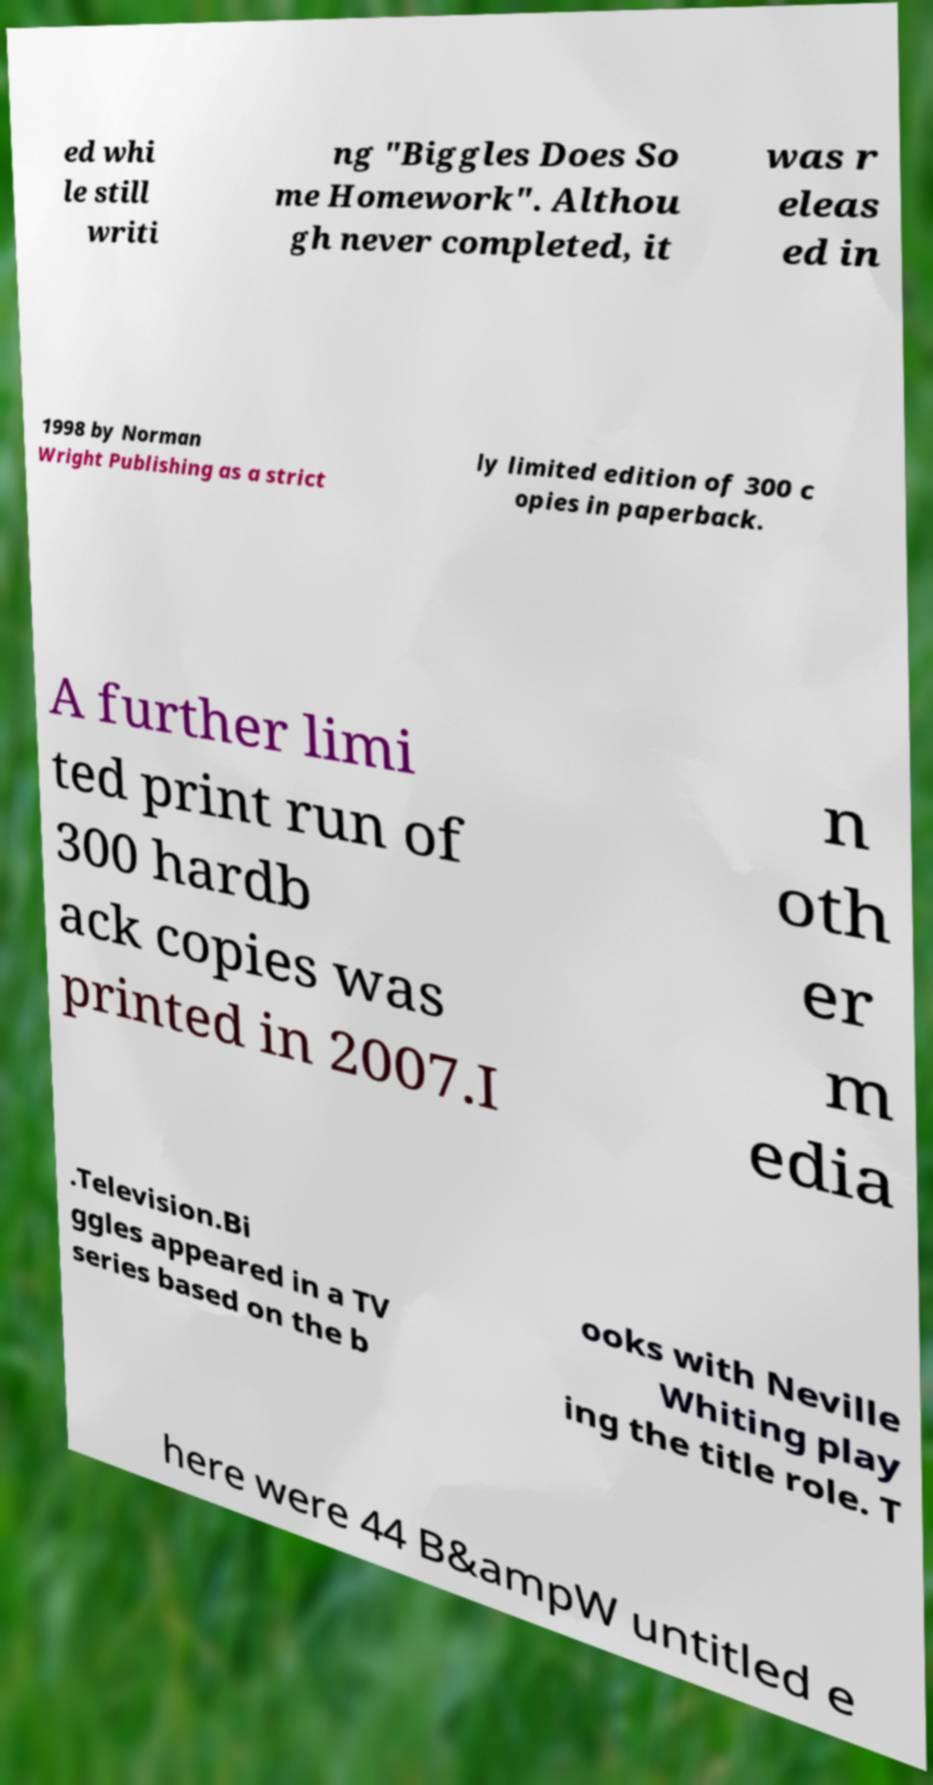What messages or text are displayed in this image? I need them in a readable, typed format. ed whi le still writi ng "Biggles Does So me Homework". Althou gh never completed, it was r eleas ed in 1998 by Norman Wright Publishing as a strict ly limited edition of 300 c opies in paperback. A further limi ted print run of 300 hardb ack copies was printed in 2007.I n oth er m edia .Television.Bi ggles appeared in a TV series based on the b ooks with Neville Whiting play ing the title role. T here were 44 B&ampW untitled e 